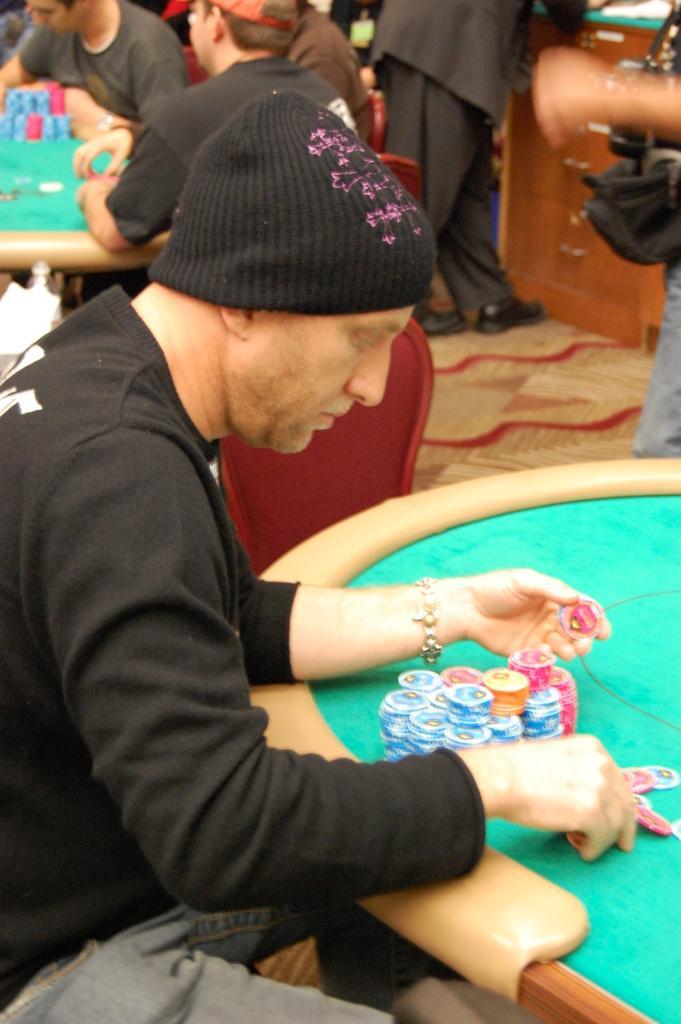How would you summarize this image in a sentence or two? On the left side of this image there is a man sitting facing towards the right side. In front of him there is a board. On the board, I can see few coins and he is holding few coins in the hands. In the background, I can see some more people sitting around the table. In the top right there is a person standing, beside him there is a table. 